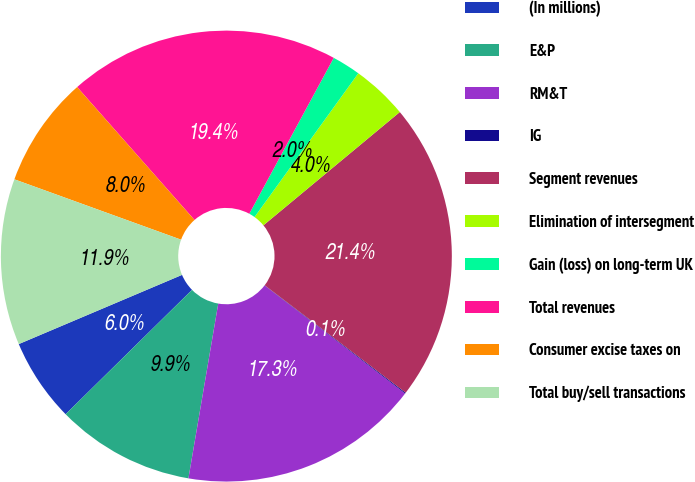Convert chart to OTSL. <chart><loc_0><loc_0><loc_500><loc_500><pie_chart><fcel>(In millions)<fcel>E&P<fcel>RM&T<fcel>IG<fcel>Segment revenues<fcel>Elimination of intersegment<fcel>Gain (loss) on long-term UK<fcel>Total revenues<fcel>Consumer excise taxes on<fcel>Total buy/sell transactions<nl><fcel>5.99%<fcel>9.94%<fcel>17.26%<fcel>0.07%<fcel>21.39%<fcel>4.02%<fcel>2.05%<fcel>19.41%<fcel>7.96%<fcel>11.91%<nl></chart> 